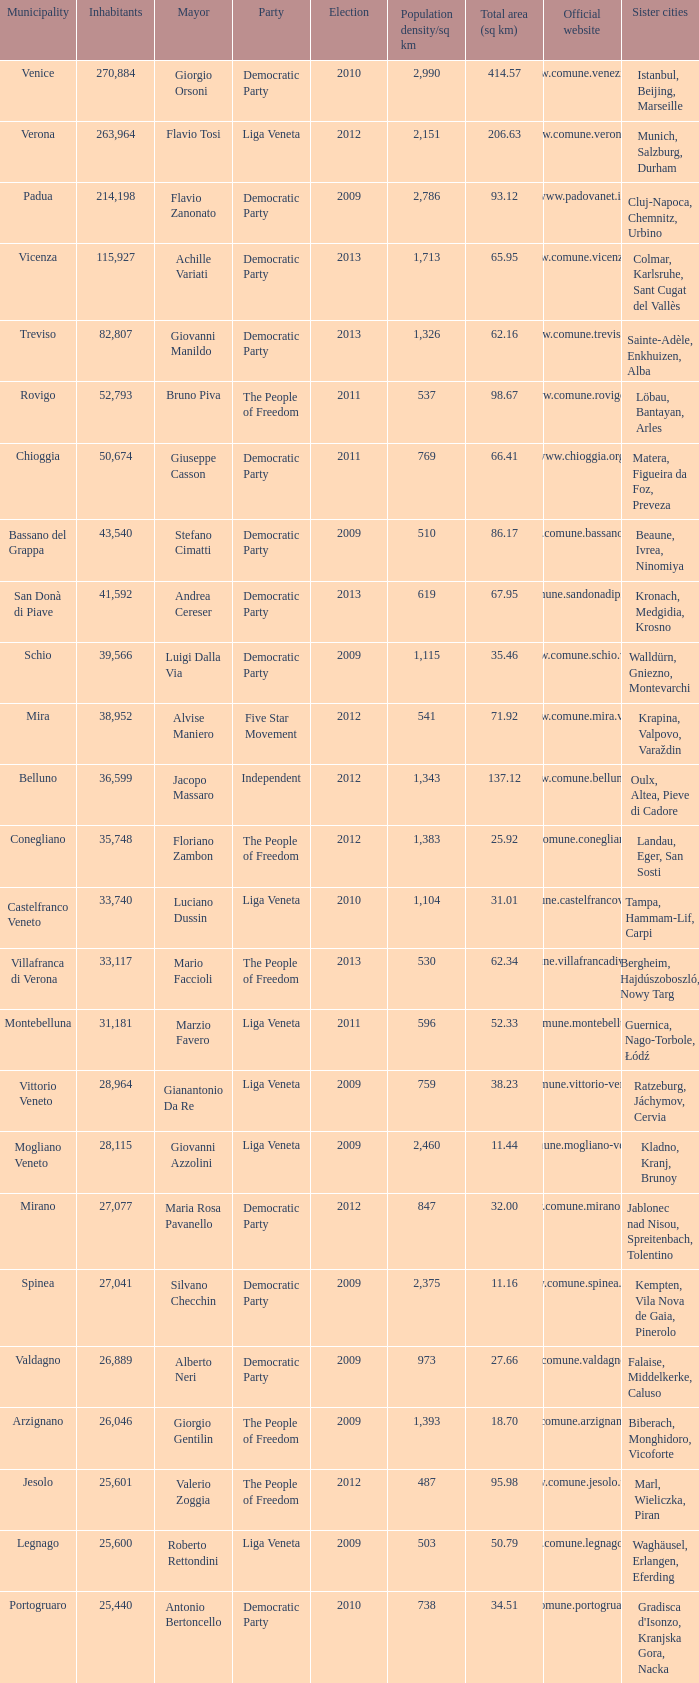In the election earlier than 2012 how many Inhabitants had a Party of five star movement? None. 